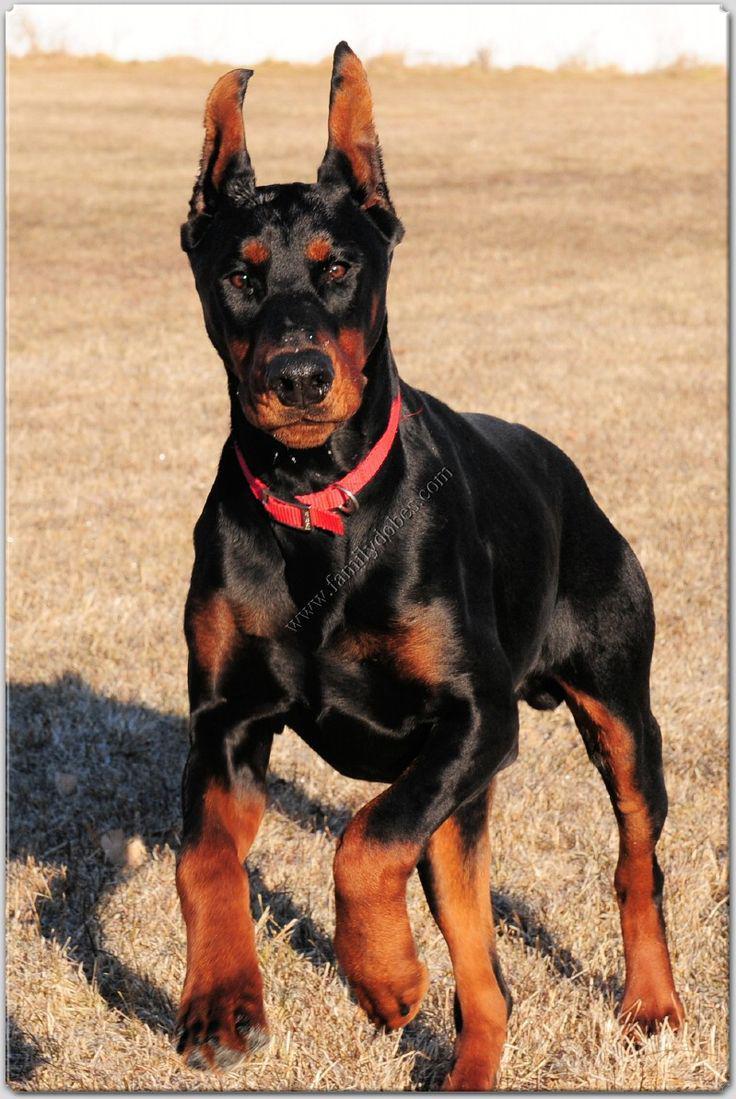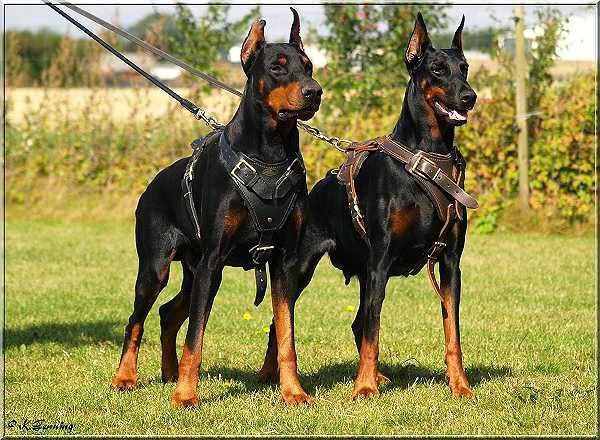The first image is the image on the left, the second image is the image on the right. For the images displayed, is the sentence "There are three dogs." factually correct? Answer yes or no. Yes. The first image is the image on the left, the second image is the image on the right. Assess this claim about the two images: "A total of three dogs, all standing, are shown, and at least two dogs are dobermans with erect pointy ears.". Correct or not? Answer yes or no. Yes. 